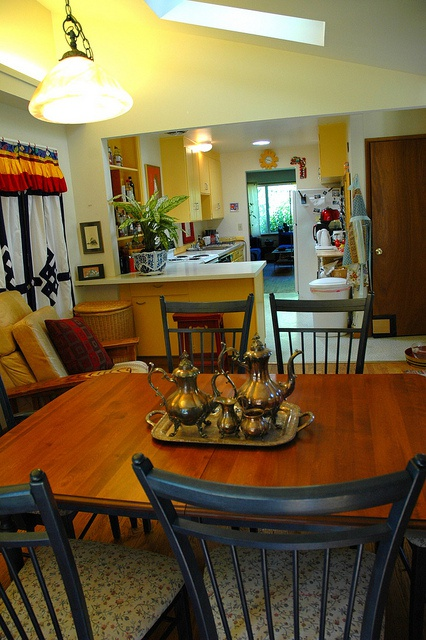Describe the objects in this image and their specific colors. I can see dining table in gold, maroon, brown, and black tones, chair in gold, black, gray, darkgreen, and darkblue tones, chair in gold, black, olive, maroon, and gray tones, chair in gold, black, olive, and maroon tones, and chair in gold, black, darkgray, olive, and lightblue tones in this image. 